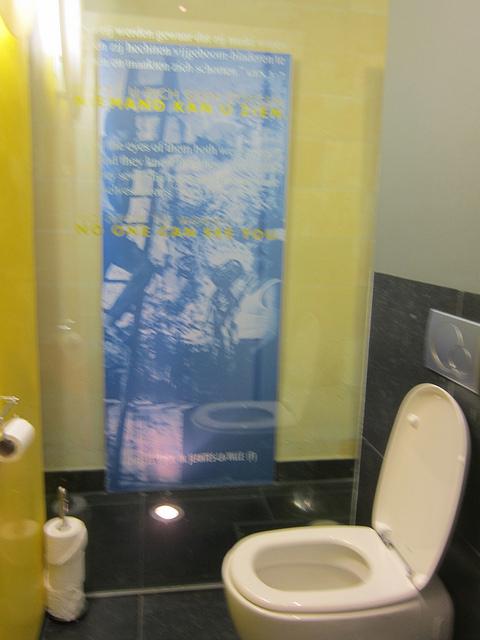What is in the background of the image?
Quick response, please. Poster. How many rolls of toilet paper do you see?
Give a very brief answer. 4. What room is this?
Answer briefly. Bathroom. 